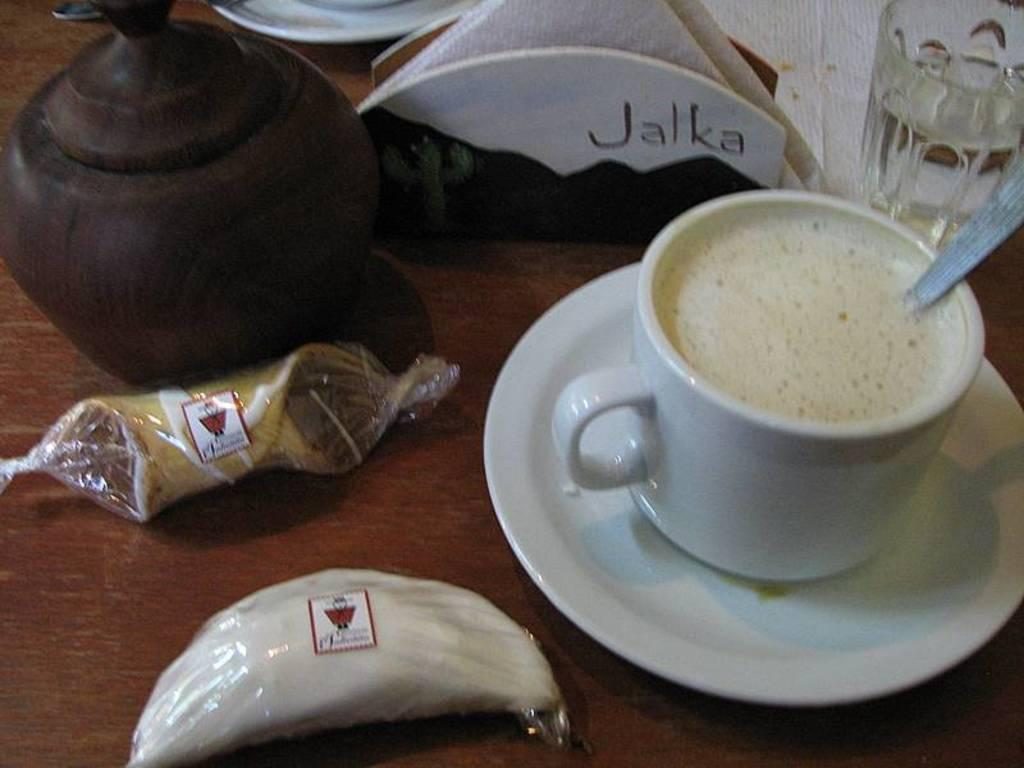What is in the cup that is visible in the image? There is milk in a white color cup in the image. Is there any additional item associated with the cup? Yes, there is a saucer associated with the cup. What can be seen in the middle of the image? There are tissues in the middle of the image. What type of wine is being poured by the beginner in the image? There is no wine or beginner present in the image; it features a cup of milk with a saucer and tissues in the middle. 